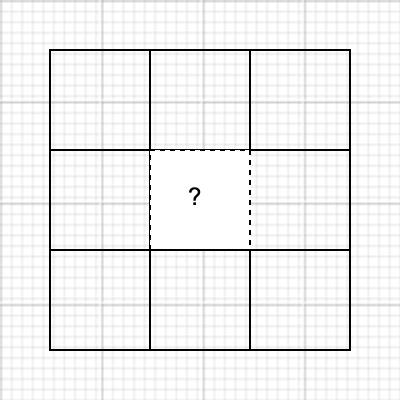In this tessellation pattern, what geometric shape should replace the question mark to complete the sequence? Consider the statistical concept of pattern recognition in your analysis. To identify the missing piece, let's analyze the pattern step-by-step:

1. Observe the overall structure:
   - The pattern is a 3x3 grid of squares.
   - Each square is 100x100 units.

2. Analyze the existing shapes:
   - Full squares: (1,1), (1,2), (2,1), (3,1), (1,3), (3,3)
   - Half squares (triangles): (2,2), (3,2), (2,3)

3. Identify the pattern:
   - Diagonal from top-left to bottom-right: full squares
   - Upper-right and lower-left corners: alternating full and half squares

4. Apply statistical pattern recognition:
   - The missing piece at (2,2) should complete the alternating pattern.
   - It should also maintain symmetry with its diagonal counterpart at (2,2).

5. Conclude the missing shape:
   - The missing piece should be a half square (triangle).
   - It should be oriented to complete the square with the half square at (2,3).

This analysis demonstrates the application of spatial pattern recognition, a crucial skill in statistical data visualization and analysis.
Answer: Right triangle (half square) 